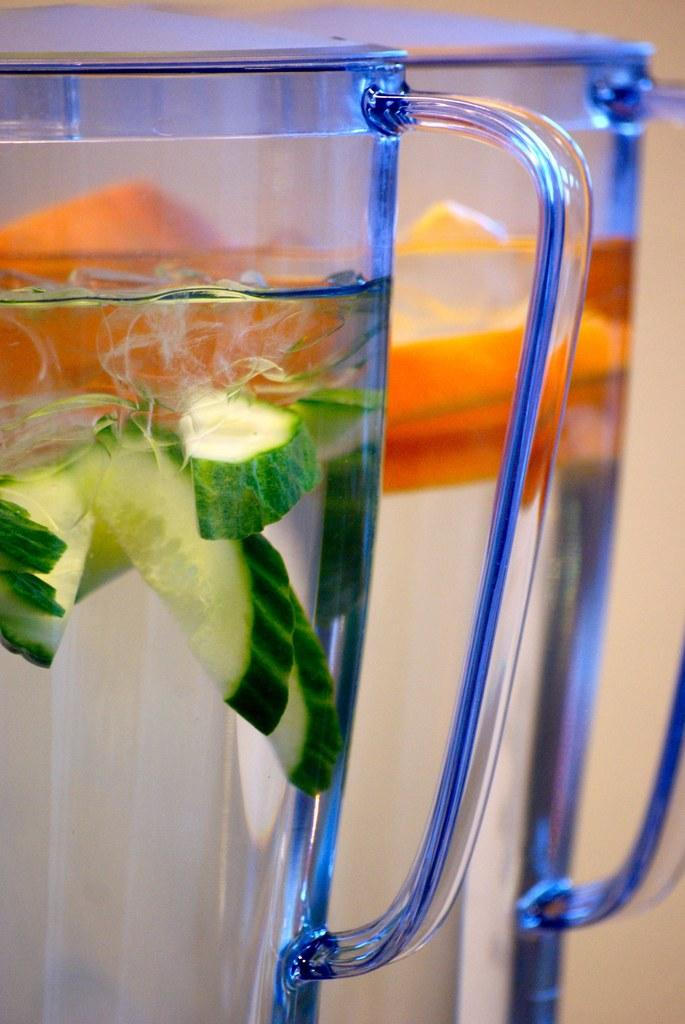What objects are present in the image? There are glasses in the image. What is inside the glasses? The glasses contain water. What else can be seen inside the glasses? There are pieces of cucumber inside the glasses. What type of pin can be seen holding the glasses together in the image? There is no pin present in the image; the glasses are not held together by any pin. 